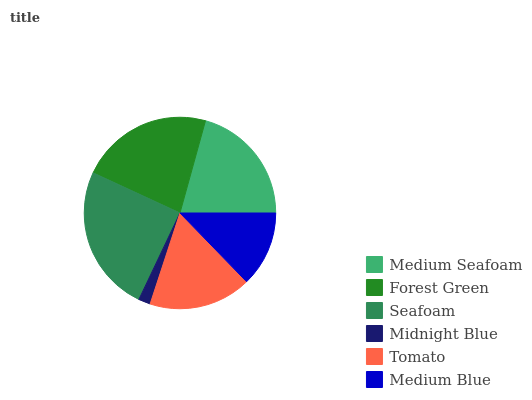Is Midnight Blue the minimum?
Answer yes or no. Yes. Is Seafoam the maximum?
Answer yes or no. Yes. Is Forest Green the minimum?
Answer yes or no. No. Is Forest Green the maximum?
Answer yes or no. No. Is Forest Green greater than Medium Seafoam?
Answer yes or no. Yes. Is Medium Seafoam less than Forest Green?
Answer yes or no. Yes. Is Medium Seafoam greater than Forest Green?
Answer yes or no. No. Is Forest Green less than Medium Seafoam?
Answer yes or no. No. Is Medium Seafoam the high median?
Answer yes or no. Yes. Is Tomato the low median?
Answer yes or no. Yes. Is Tomato the high median?
Answer yes or no. No. Is Seafoam the low median?
Answer yes or no. No. 